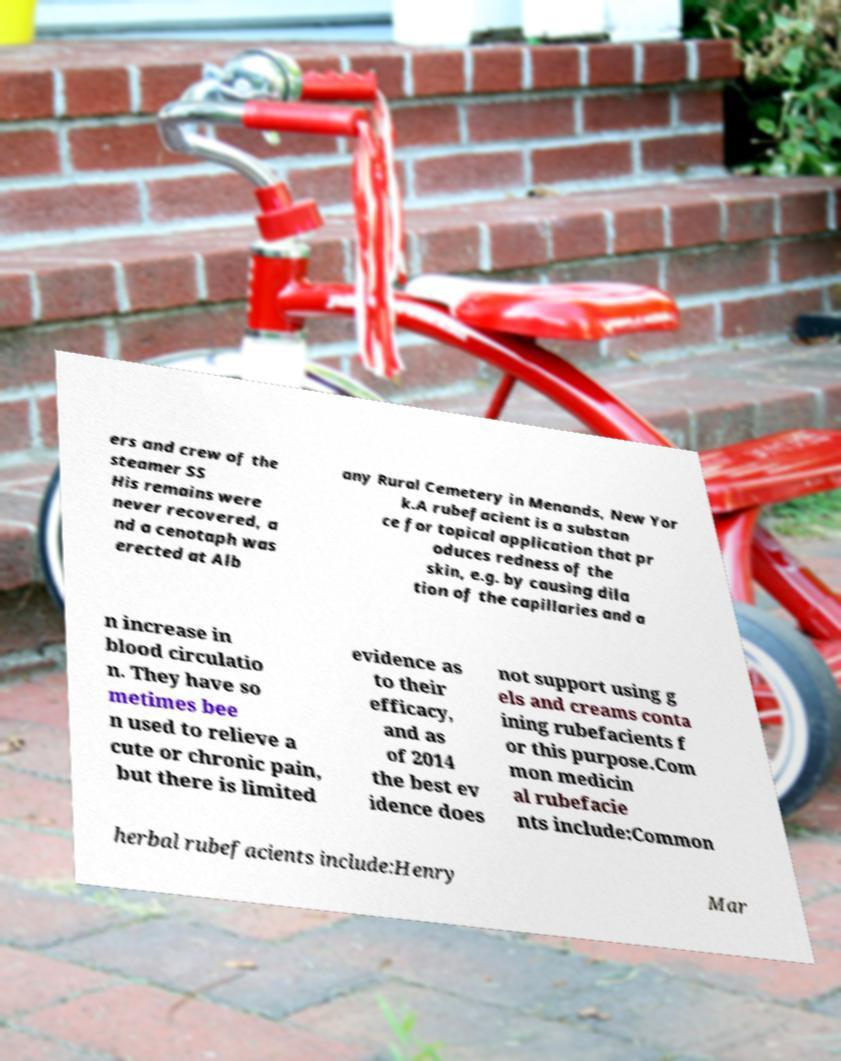I need the written content from this picture converted into text. Can you do that? ers and crew of the steamer SS His remains were never recovered, a nd a cenotaph was erected at Alb any Rural Cemetery in Menands, New Yor k.A rubefacient is a substan ce for topical application that pr oduces redness of the skin, e.g. by causing dila tion of the capillaries and a n increase in blood circulatio n. They have so metimes bee n used to relieve a cute or chronic pain, but there is limited evidence as to their efficacy, and as of 2014 the best ev idence does not support using g els and creams conta ining rubefacients f or this purpose.Com mon medicin al rubefacie nts include:Common herbal rubefacients include:Henry Mar 